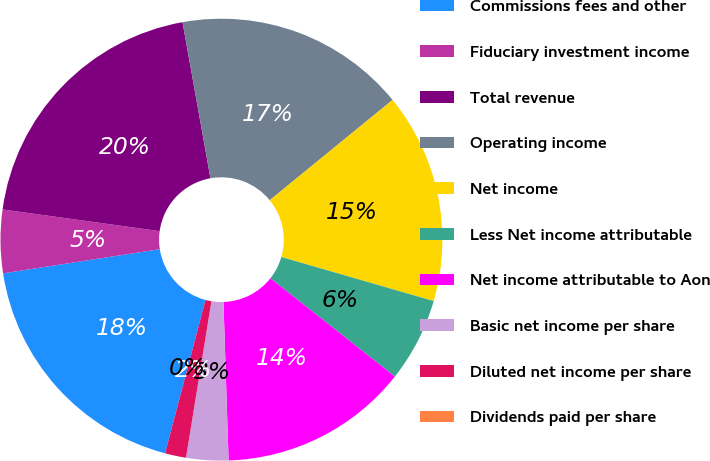Convert chart. <chart><loc_0><loc_0><loc_500><loc_500><pie_chart><fcel>Commissions fees and other<fcel>Fiduciary investment income<fcel>Total revenue<fcel>Operating income<fcel>Net income<fcel>Less Net income attributable<fcel>Net income attributable to Aon<fcel>Basic net income per share<fcel>Diluted net income per share<fcel>Dividends paid per share<nl><fcel>18.46%<fcel>4.62%<fcel>20.0%<fcel>16.92%<fcel>15.38%<fcel>6.15%<fcel>13.85%<fcel>3.08%<fcel>1.54%<fcel>0.0%<nl></chart> 